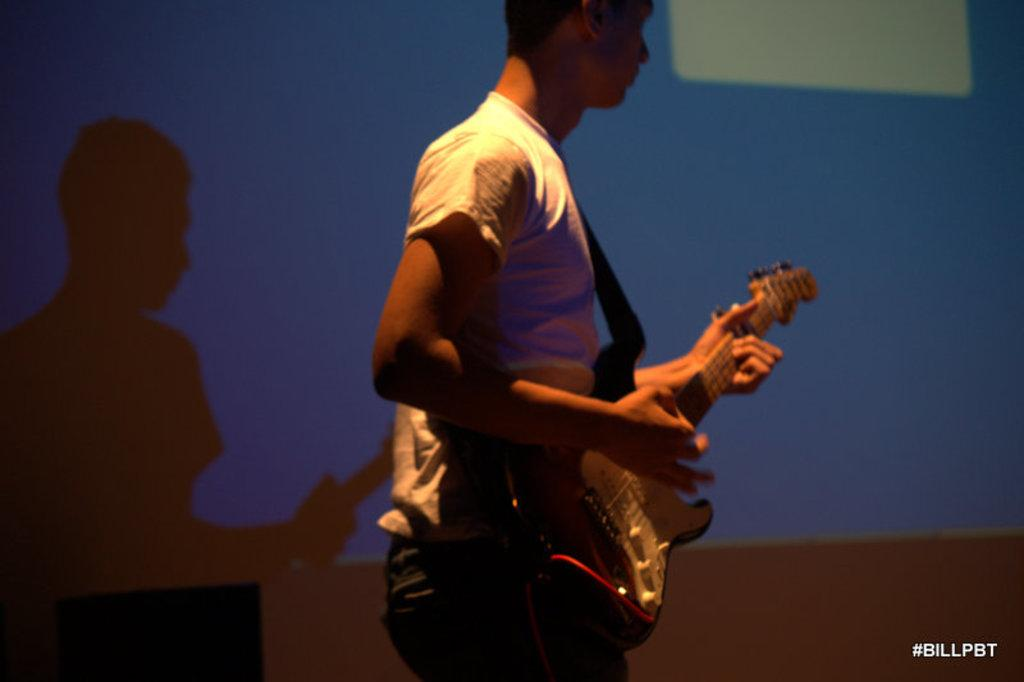What is the person in the picture doing? The person is playing a guitar. What is the person wearing? The person is wearing a white t-shirt and jeans. What can be seen behind the person? There is a screen behind the person. How many boys are wearing jeans in the image? There is only one person in the image, and they are wearing jeans, but we cannot determine their gender from the information provided. 